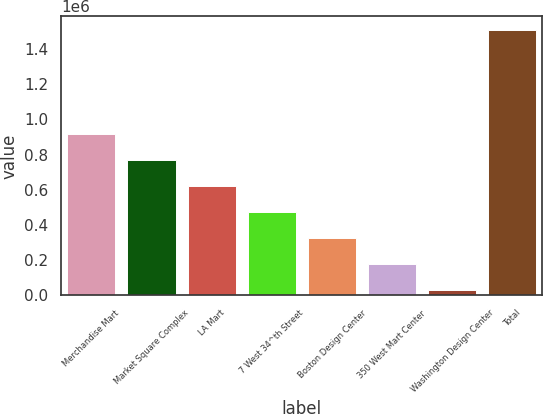Convert chart. <chart><loc_0><loc_0><loc_500><loc_500><bar_chart><fcel>Merchandise Mart<fcel>Market Square Complex<fcel>LA Mart<fcel>7 West 34^th Street<fcel>Boston Design Center<fcel>350 West Mart Center<fcel>Washington Design Center<fcel>Total<nl><fcel>917600<fcel>769500<fcel>621400<fcel>473300<fcel>325200<fcel>177100<fcel>29000<fcel>1.51e+06<nl></chart> 